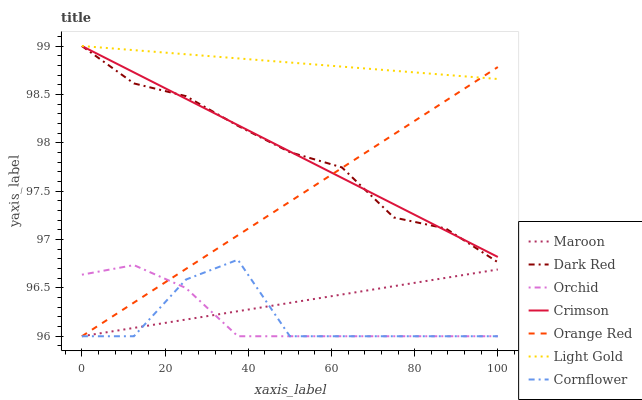Does Cornflower have the minimum area under the curve?
Answer yes or no. Yes. Does Light Gold have the maximum area under the curve?
Answer yes or no. Yes. Does Dark Red have the minimum area under the curve?
Answer yes or no. No. Does Dark Red have the maximum area under the curve?
Answer yes or no. No. Is Light Gold the smoothest?
Answer yes or no. Yes. Is Cornflower the roughest?
Answer yes or no. Yes. Is Dark Red the smoothest?
Answer yes or no. No. Is Dark Red the roughest?
Answer yes or no. No. Does Cornflower have the lowest value?
Answer yes or no. Yes. Does Dark Red have the lowest value?
Answer yes or no. No. Does Light Gold have the highest value?
Answer yes or no. Yes. Does Maroon have the highest value?
Answer yes or no. No. Is Orchid less than Light Gold?
Answer yes or no. Yes. Is Light Gold greater than Maroon?
Answer yes or no. Yes. Does Orange Red intersect Orchid?
Answer yes or no. Yes. Is Orange Red less than Orchid?
Answer yes or no. No. Is Orange Red greater than Orchid?
Answer yes or no. No. Does Orchid intersect Light Gold?
Answer yes or no. No. 